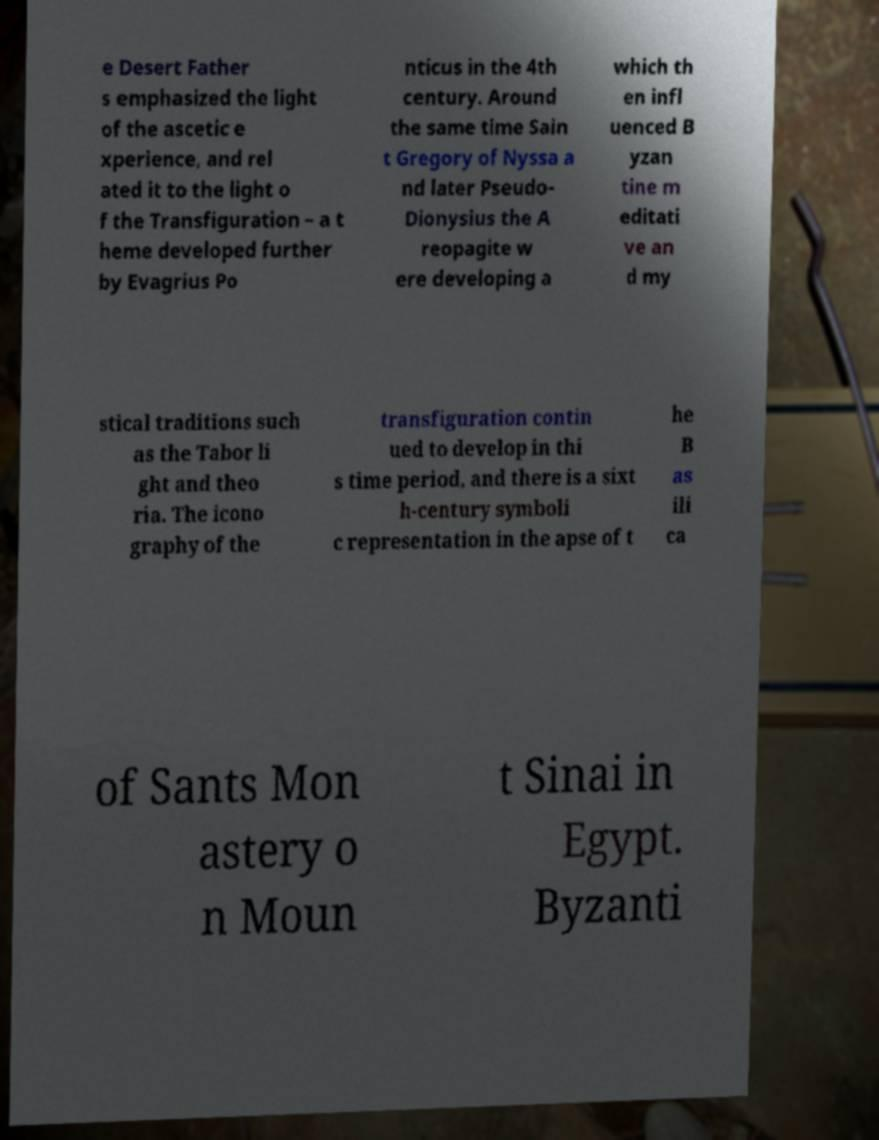There's text embedded in this image that I need extracted. Can you transcribe it verbatim? e Desert Father s emphasized the light of the ascetic e xperience, and rel ated it to the light o f the Transfiguration – a t heme developed further by Evagrius Po nticus in the 4th century. Around the same time Sain t Gregory of Nyssa a nd later Pseudo- Dionysius the A reopagite w ere developing a which th en infl uenced B yzan tine m editati ve an d my stical traditions such as the Tabor li ght and theo ria. The icono graphy of the transfiguration contin ued to develop in thi s time period, and there is a sixt h-century symboli c representation in the apse of t he B as ili ca of Sants Mon astery o n Moun t Sinai in Egypt. Byzanti 